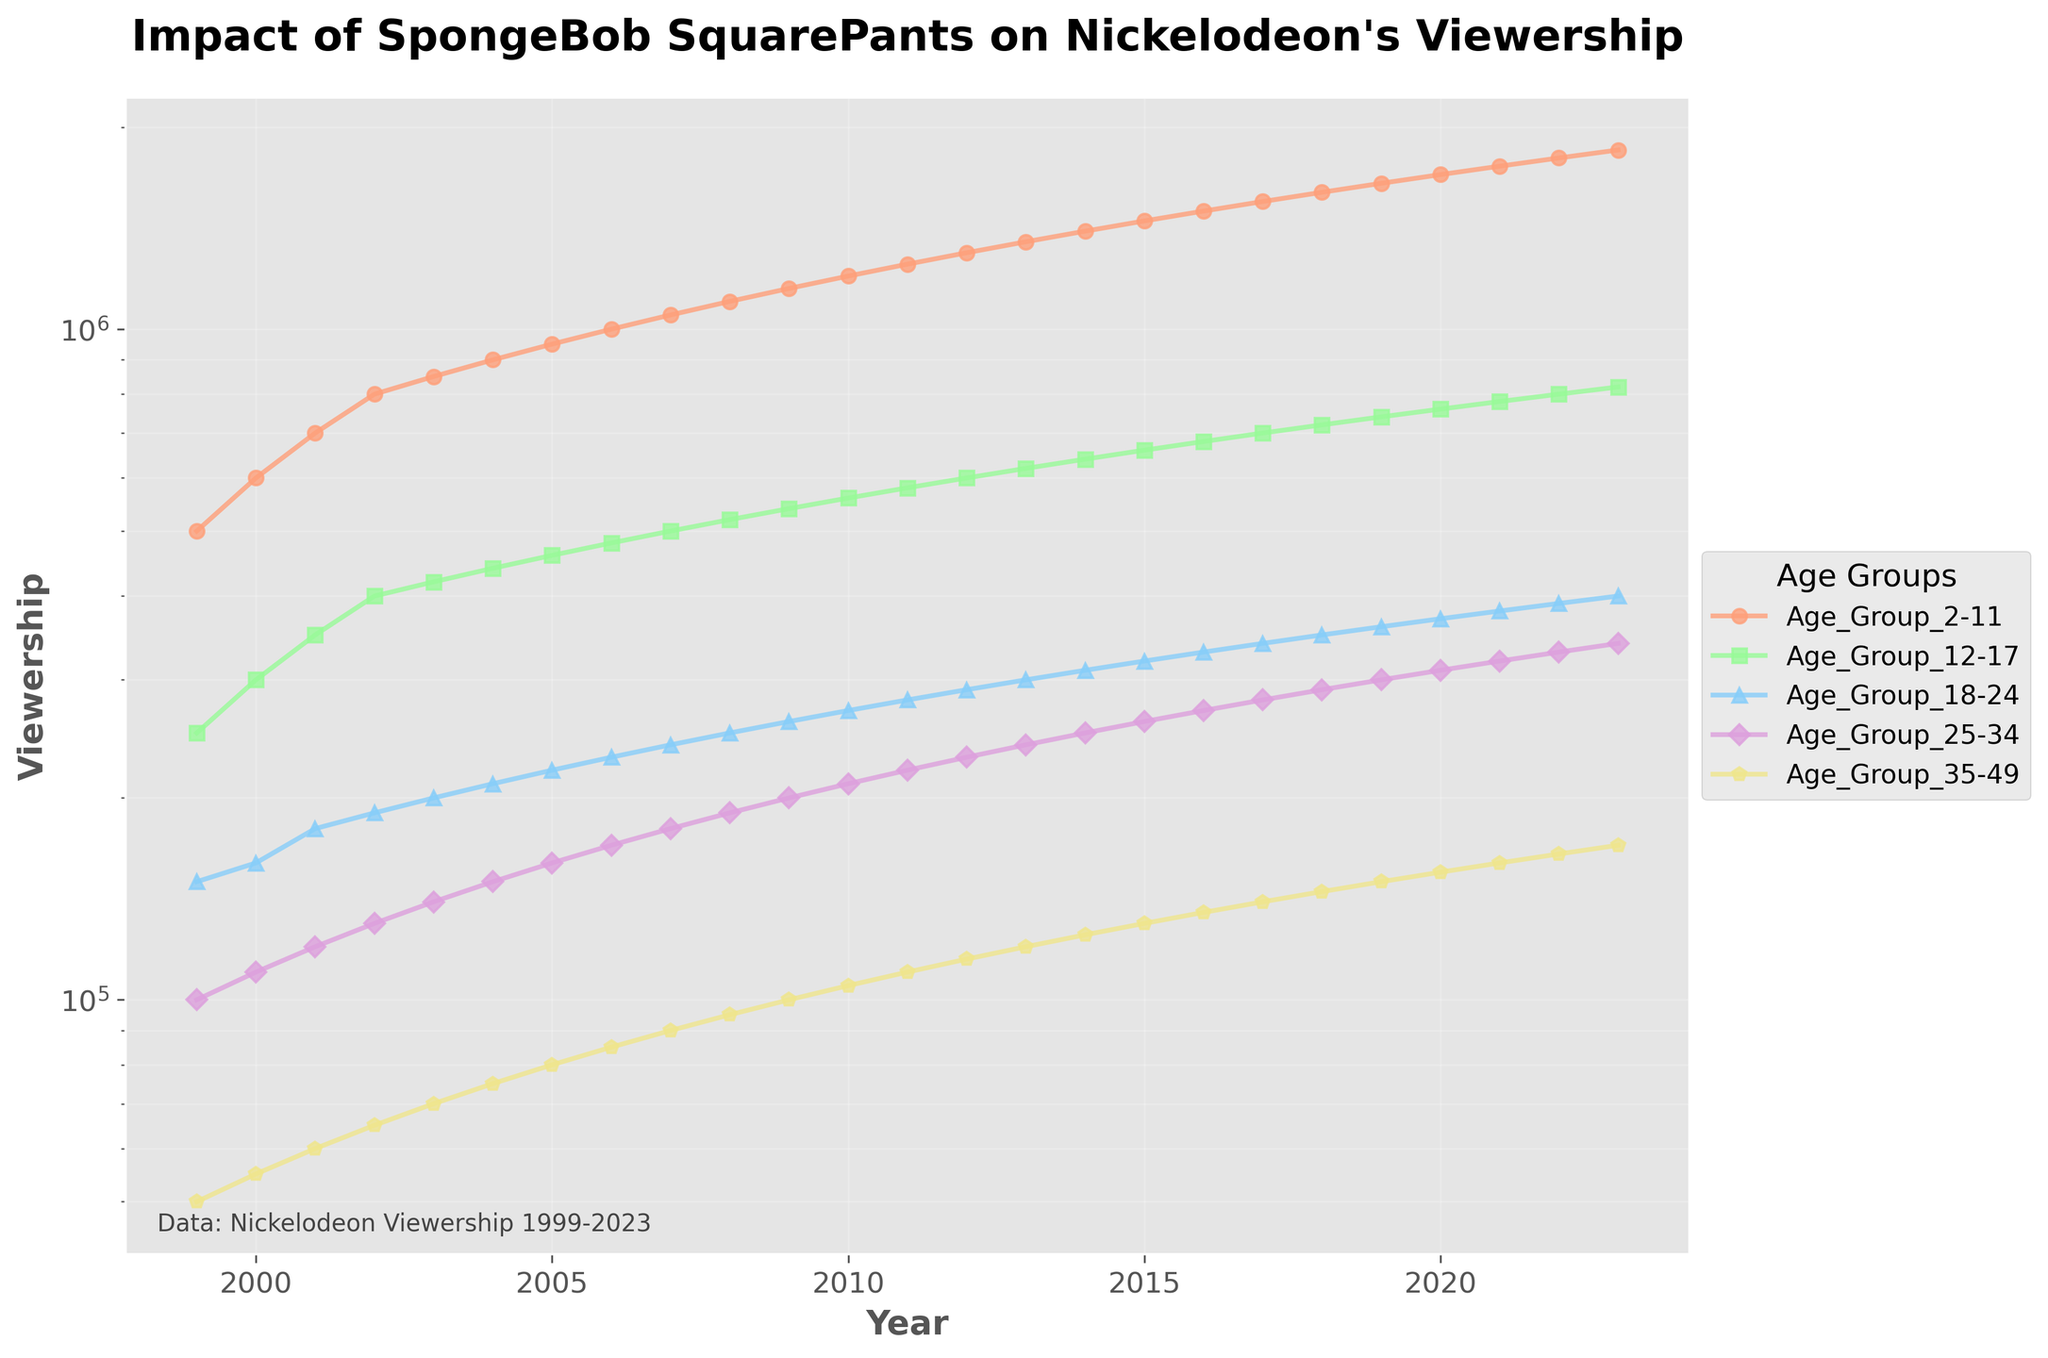What is the title of the plot? The title is displayed at the top of the plot and provides a summary of what the plot represents.
Answer: Impact of SpongeBob SquarePants on Nickelodeon's Viewership Which age group had the highest viewership in 2005? By identifying the data points for each age group in 2005, we see that the age group 2-11 has the highest viewership.
Answer: Age_Group_2-11 What is the viewership trend for the age group 18-24 from 1999 to 2023? By following the line associated with the 18-24 age group, we observe a steady upward trend in viewership from 150,000 in 1999 to 400,000 in 2023.
Answer: Steadily increasing How does the viewership for the age group 25-34 in 2010 compare to that in 2020? By locating the data points for age group 25-34 in 2010 and 2020, we see that it increased from 210,000 in 2010 to 310,000 in 2020.
Answer: Increased Which age group's viewership had the smallest growth from 1999 to 2023? By examining the overall viewership growth for each age group from 1999 to 2023, we see that the age group 35-49 had the smallest increase, from 50,000 to 170,000.
Answer: Age_Group_35-49 What is the difference in viewership between the age group 2-11 and the age group 12-17 for the year 2023? Subtracting the viewership of age group 12-17 from age group 2-11 for the year 2023: 1,850,000 - 820,000 = 1,030,000.
Answer: 1,030,000 Which year did the age group 2-11 surpass 1,000,000 in viewership? By tracing the data points for age group 2-11, we see that the viewership surpassed 1,000,000 in 2006.
Answer: 2006 What is the average viewership for the age group 35-49 over the period 1999-2023? Sum the viewership values from 1999 to 2023 and divide by the number of years. (50,000 + 55,000 + 60,000 + ... + 170,000) / 25 = 110,000.
Answer: 110,000 Which two age groups had a similar viewership around the year 2015? By comparing the data points around 2015, the age groups 12-17 and 18-24 had a similar viewership, with approximately 660,000 and 320,000, respectively.
Answer: Age_Group_12-17 and Age_Group_18-24 What is the pattern observed in the log scale for the viewership data? The log scale compresses the range and highlights the exponential growth across different age groups. All lines showing upward trends appear less steep compared to a linear scale, indicating the growth rate is exponentially smoothed.
Answer: Exponential growth 